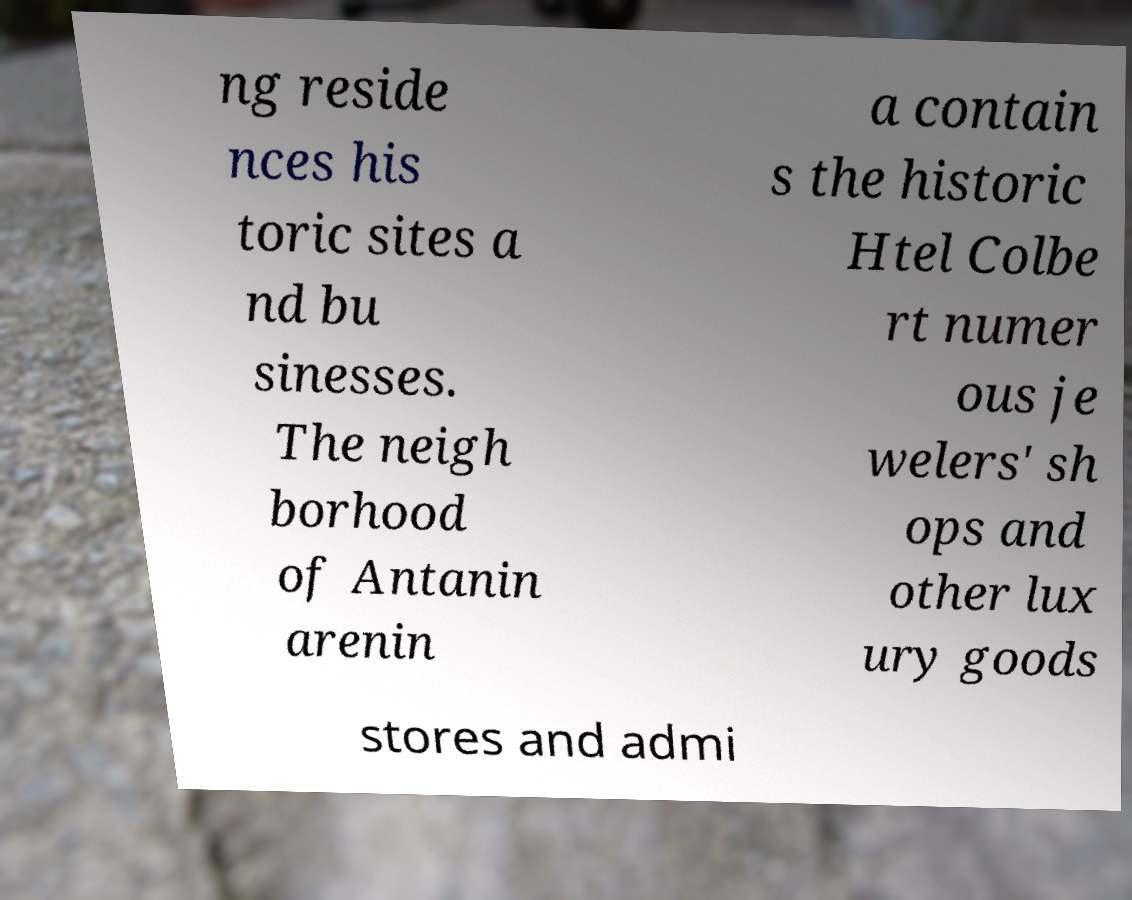I need the written content from this picture converted into text. Can you do that? ng reside nces his toric sites a nd bu sinesses. The neigh borhood of Antanin arenin a contain s the historic Htel Colbe rt numer ous je welers' sh ops and other lux ury goods stores and admi 